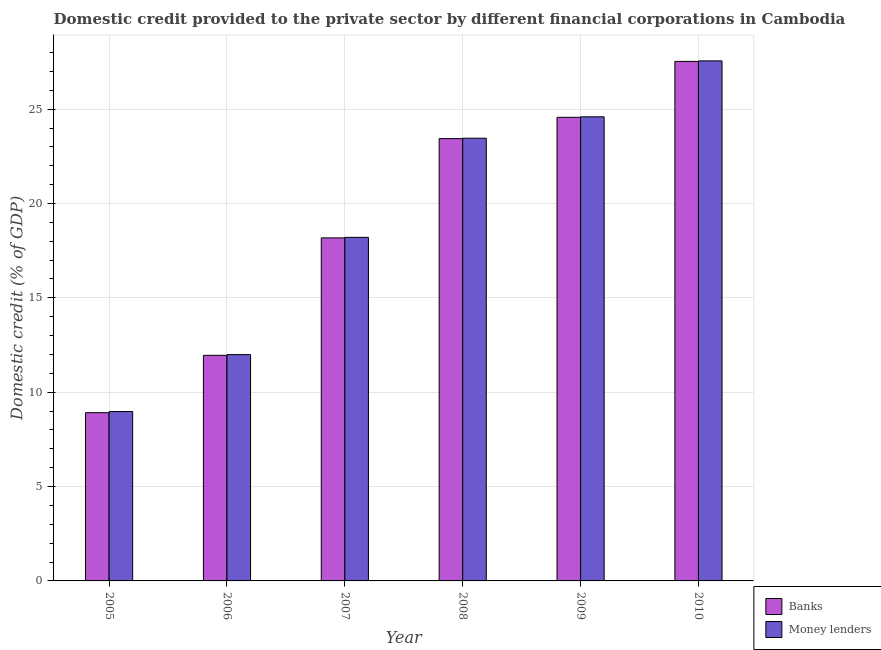How many different coloured bars are there?
Offer a very short reply. 2. How many groups of bars are there?
Your answer should be compact. 6. Are the number of bars per tick equal to the number of legend labels?
Offer a terse response. Yes. Are the number of bars on each tick of the X-axis equal?
Your answer should be compact. Yes. How many bars are there on the 3rd tick from the left?
Your answer should be very brief. 2. How many bars are there on the 5th tick from the right?
Make the answer very short. 2. What is the label of the 1st group of bars from the left?
Your answer should be very brief. 2005. What is the domestic credit provided by banks in 2006?
Provide a short and direct response. 11.95. Across all years, what is the maximum domestic credit provided by banks?
Provide a succinct answer. 27.53. Across all years, what is the minimum domestic credit provided by banks?
Provide a succinct answer. 8.92. In which year was the domestic credit provided by money lenders minimum?
Provide a short and direct response. 2005. What is the total domestic credit provided by money lenders in the graph?
Offer a very short reply. 114.79. What is the difference between the domestic credit provided by money lenders in 2006 and that in 2008?
Offer a terse response. -11.47. What is the difference between the domestic credit provided by money lenders in 2009 and the domestic credit provided by banks in 2006?
Your answer should be compact. 12.6. What is the average domestic credit provided by money lenders per year?
Offer a very short reply. 19.13. In how many years, is the domestic credit provided by money lenders greater than 5 %?
Your answer should be very brief. 6. What is the ratio of the domestic credit provided by banks in 2009 to that in 2010?
Offer a terse response. 0.89. What is the difference between the highest and the second highest domestic credit provided by money lenders?
Provide a succinct answer. 2.96. What is the difference between the highest and the lowest domestic credit provided by banks?
Ensure brevity in your answer.  18.61. What does the 1st bar from the left in 2008 represents?
Offer a terse response. Banks. What does the 1st bar from the right in 2006 represents?
Offer a terse response. Money lenders. How many years are there in the graph?
Your response must be concise. 6. Are the values on the major ticks of Y-axis written in scientific E-notation?
Provide a succinct answer. No. Where does the legend appear in the graph?
Offer a very short reply. Bottom right. How many legend labels are there?
Give a very brief answer. 2. How are the legend labels stacked?
Your answer should be compact. Vertical. What is the title of the graph?
Offer a terse response. Domestic credit provided to the private sector by different financial corporations in Cambodia. Does "Forest land" appear as one of the legend labels in the graph?
Your answer should be very brief. No. What is the label or title of the X-axis?
Keep it short and to the point. Year. What is the label or title of the Y-axis?
Provide a short and direct response. Domestic credit (% of GDP). What is the Domestic credit (% of GDP) in Banks in 2005?
Give a very brief answer. 8.92. What is the Domestic credit (% of GDP) in Money lenders in 2005?
Your answer should be compact. 8.98. What is the Domestic credit (% of GDP) of Banks in 2006?
Offer a very short reply. 11.95. What is the Domestic credit (% of GDP) in Money lenders in 2006?
Your answer should be compact. 11.99. What is the Domestic credit (% of GDP) in Banks in 2007?
Give a very brief answer. 18.18. What is the Domestic credit (% of GDP) in Money lenders in 2007?
Keep it short and to the point. 18.21. What is the Domestic credit (% of GDP) of Banks in 2008?
Ensure brevity in your answer.  23.44. What is the Domestic credit (% of GDP) in Money lenders in 2008?
Your answer should be very brief. 23.46. What is the Domestic credit (% of GDP) in Banks in 2009?
Your answer should be compact. 24.57. What is the Domestic credit (% of GDP) of Money lenders in 2009?
Ensure brevity in your answer.  24.59. What is the Domestic credit (% of GDP) of Banks in 2010?
Make the answer very short. 27.53. What is the Domestic credit (% of GDP) of Money lenders in 2010?
Offer a very short reply. 27.56. Across all years, what is the maximum Domestic credit (% of GDP) in Banks?
Offer a terse response. 27.53. Across all years, what is the maximum Domestic credit (% of GDP) in Money lenders?
Your answer should be compact. 27.56. Across all years, what is the minimum Domestic credit (% of GDP) of Banks?
Offer a very short reply. 8.92. Across all years, what is the minimum Domestic credit (% of GDP) of Money lenders?
Give a very brief answer. 8.98. What is the total Domestic credit (% of GDP) of Banks in the graph?
Your answer should be very brief. 114.58. What is the total Domestic credit (% of GDP) in Money lenders in the graph?
Provide a succinct answer. 114.79. What is the difference between the Domestic credit (% of GDP) of Banks in 2005 and that in 2006?
Offer a terse response. -3.04. What is the difference between the Domestic credit (% of GDP) of Money lenders in 2005 and that in 2006?
Make the answer very short. -3.02. What is the difference between the Domestic credit (% of GDP) of Banks in 2005 and that in 2007?
Keep it short and to the point. -9.26. What is the difference between the Domestic credit (% of GDP) in Money lenders in 2005 and that in 2007?
Keep it short and to the point. -9.23. What is the difference between the Domestic credit (% of GDP) of Banks in 2005 and that in 2008?
Ensure brevity in your answer.  -14.52. What is the difference between the Domestic credit (% of GDP) in Money lenders in 2005 and that in 2008?
Provide a succinct answer. -14.48. What is the difference between the Domestic credit (% of GDP) in Banks in 2005 and that in 2009?
Your answer should be very brief. -15.65. What is the difference between the Domestic credit (% of GDP) in Money lenders in 2005 and that in 2009?
Ensure brevity in your answer.  -15.62. What is the difference between the Domestic credit (% of GDP) in Banks in 2005 and that in 2010?
Your answer should be very brief. -18.61. What is the difference between the Domestic credit (% of GDP) in Money lenders in 2005 and that in 2010?
Offer a very short reply. -18.58. What is the difference between the Domestic credit (% of GDP) in Banks in 2006 and that in 2007?
Ensure brevity in your answer.  -6.22. What is the difference between the Domestic credit (% of GDP) of Money lenders in 2006 and that in 2007?
Offer a very short reply. -6.21. What is the difference between the Domestic credit (% of GDP) of Banks in 2006 and that in 2008?
Ensure brevity in your answer.  -11.49. What is the difference between the Domestic credit (% of GDP) in Money lenders in 2006 and that in 2008?
Ensure brevity in your answer.  -11.47. What is the difference between the Domestic credit (% of GDP) of Banks in 2006 and that in 2009?
Give a very brief answer. -12.61. What is the difference between the Domestic credit (% of GDP) of Money lenders in 2006 and that in 2009?
Your answer should be very brief. -12.6. What is the difference between the Domestic credit (% of GDP) in Banks in 2006 and that in 2010?
Your answer should be compact. -15.58. What is the difference between the Domestic credit (% of GDP) in Money lenders in 2006 and that in 2010?
Your answer should be compact. -15.57. What is the difference between the Domestic credit (% of GDP) of Banks in 2007 and that in 2008?
Your answer should be very brief. -5.26. What is the difference between the Domestic credit (% of GDP) of Money lenders in 2007 and that in 2008?
Offer a very short reply. -5.25. What is the difference between the Domestic credit (% of GDP) of Banks in 2007 and that in 2009?
Offer a very short reply. -6.39. What is the difference between the Domestic credit (% of GDP) of Money lenders in 2007 and that in 2009?
Your response must be concise. -6.39. What is the difference between the Domestic credit (% of GDP) of Banks in 2007 and that in 2010?
Ensure brevity in your answer.  -9.35. What is the difference between the Domestic credit (% of GDP) of Money lenders in 2007 and that in 2010?
Keep it short and to the point. -9.35. What is the difference between the Domestic credit (% of GDP) in Banks in 2008 and that in 2009?
Give a very brief answer. -1.13. What is the difference between the Domestic credit (% of GDP) in Money lenders in 2008 and that in 2009?
Your response must be concise. -1.13. What is the difference between the Domestic credit (% of GDP) of Banks in 2008 and that in 2010?
Provide a short and direct response. -4.09. What is the difference between the Domestic credit (% of GDP) in Money lenders in 2008 and that in 2010?
Offer a very short reply. -4.1. What is the difference between the Domestic credit (% of GDP) of Banks in 2009 and that in 2010?
Make the answer very short. -2.96. What is the difference between the Domestic credit (% of GDP) in Money lenders in 2009 and that in 2010?
Your answer should be very brief. -2.96. What is the difference between the Domestic credit (% of GDP) in Banks in 2005 and the Domestic credit (% of GDP) in Money lenders in 2006?
Offer a terse response. -3.08. What is the difference between the Domestic credit (% of GDP) of Banks in 2005 and the Domestic credit (% of GDP) of Money lenders in 2007?
Keep it short and to the point. -9.29. What is the difference between the Domestic credit (% of GDP) of Banks in 2005 and the Domestic credit (% of GDP) of Money lenders in 2008?
Provide a short and direct response. -14.54. What is the difference between the Domestic credit (% of GDP) in Banks in 2005 and the Domestic credit (% of GDP) in Money lenders in 2009?
Your response must be concise. -15.68. What is the difference between the Domestic credit (% of GDP) of Banks in 2005 and the Domestic credit (% of GDP) of Money lenders in 2010?
Provide a short and direct response. -18.64. What is the difference between the Domestic credit (% of GDP) of Banks in 2006 and the Domestic credit (% of GDP) of Money lenders in 2007?
Offer a very short reply. -6.25. What is the difference between the Domestic credit (% of GDP) in Banks in 2006 and the Domestic credit (% of GDP) in Money lenders in 2008?
Offer a terse response. -11.51. What is the difference between the Domestic credit (% of GDP) of Banks in 2006 and the Domestic credit (% of GDP) of Money lenders in 2009?
Make the answer very short. -12.64. What is the difference between the Domestic credit (% of GDP) of Banks in 2006 and the Domestic credit (% of GDP) of Money lenders in 2010?
Ensure brevity in your answer.  -15.6. What is the difference between the Domestic credit (% of GDP) in Banks in 2007 and the Domestic credit (% of GDP) in Money lenders in 2008?
Give a very brief answer. -5.28. What is the difference between the Domestic credit (% of GDP) in Banks in 2007 and the Domestic credit (% of GDP) in Money lenders in 2009?
Provide a succinct answer. -6.42. What is the difference between the Domestic credit (% of GDP) of Banks in 2007 and the Domestic credit (% of GDP) of Money lenders in 2010?
Provide a short and direct response. -9.38. What is the difference between the Domestic credit (% of GDP) in Banks in 2008 and the Domestic credit (% of GDP) in Money lenders in 2009?
Make the answer very short. -1.15. What is the difference between the Domestic credit (% of GDP) in Banks in 2008 and the Domestic credit (% of GDP) in Money lenders in 2010?
Make the answer very short. -4.12. What is the difference between the Domestic credit (% of GDP) of Banks in 2009 and the Domestic credit (% of GDP) of Money lenders in 2010?
Give a very brief answer. -2.99. What is the average Domestic credit (% of GDP) in Banks per year?
Your response must be concise. 19.1. What is the average Domestic credit (% of GDP) in Money lenders per year?
Offer a very short reply. 19.13. In the year 2005, what is the difference between the Domestic credit (% of GDP) of Banks and Domestic credit (% of GDP) of Money lenders?
Offer a very short reply. -0.06. In the year 2006, what is the difference between the Domestic credit (% of GDP) of Banks and Domestic credit (% of GDP) of Money lenders?
Your response must be concise. -0.04. In the year 2007, what is the difference between the Domestic credit (% of GDP) in Banks and Domestic credit (% of GDP) in Money lenders?
Ensure brevity in your answer.  -0.03. In the year 2008, what is the difference between the Domestic credit (% of GDP) of Banks and Domestic credit (% of GDP) of Money lenders?
Offer a very short reply. -0.02. In the year 2009, what is the difference between the Domestic credit (% of GDP) in Banks and Domestic credit (% of GDP) in Money lenders?
Ensure brevity in your answer.  -0.03. In the year 2010, what is the difference between the Domestic credit (% of GDP) in Banks and Domestic credit (% of GDP) in Money lenders?
Keep it short and to the point. -0.03. What is the ratio of the Domestic credit (% of GDP) of Banks in 2005 to that in 2006?
Provide a short and direct response. 0.75. What is the ratio of the Domestic credit (% of GDP) in Money lenders in 2005 to that in 2006?
Offer a terse response. 0.75. What is the ratio of the Domestic credit (% of GDP) of Banks in 2005 to that in 2007?
Keep it short and to the point. 0.49. What is the ratio of the Domestic credit (% of GDP) of Money lenders in 2005 to that in 2007?
Offer a very short reply. 0.49. What is the ratio of the Domestic credit (% of GDP) of Banks in 2005 to that in 2008?
Ensure brevity in your answer.  0.38. What is the ratio of the Domestic credit (% of GDP) of Money lenders in 2005 to that in 2008?
Offer a terse response. 0.38. What is the ratio of the Domestic credit (% of GDP) in Banks in 2005 to that in 2009?
Give a very brief answer. 0.36. What is the ratio of the Domestic credit (% of GDP) in Money lenders in 2005 to that in 2009?
Offer a very short reply. 0.36. What is the ratio of the Domestic credit (% of GDP) in Banks in 2005 to that in 2010?
Your response must be concise. 0.32. What is the ratio of the Domestic credit (% of GDP) in Money lenders in 2005 to that in 2010?
Keep it short and to the point. 0.33. What is the ratio of the Domestic credit (% of GDP) of Banks in 2006 to that in 2007?
Keep it short and to the point. 0.66. What is the ratio of the Domestic credit (% of GDP) in Money lenders in 2006 to that in 2007?
Make the answer very short. 0.66. What is the ratio of the Domestic credit (% of GDP) in Banks in 2006 to that in 2008?
Offer a terse response. 0.51. What is the ratio of the Domestic credit (% of GDP) of Money lenders in 2006 to that in 2008?
Offer a very short reply. 0.51. What is the ratio of the Domestic credit (% of GDP) in Banks in 2006 to that in 2009?
Ensure brevity in your answer.  0.49. What is the ratio of the Domestic credit (% of GDP) in Money lenders in 2006 to that in 2009?
Make the answer very short. 0.49. What is the ratio of the Domestic credit (% of GDP) of Banks in 2006 to that in 2010?
Your response must be concise. 0.43. What is the ratio of the Domestic credit (% of GDP) in Money lenders in 2006 to that in 2010?
Provide a succinct answer. 0.44. What is the ratio of the Domestic credit (% of GDP) of Banks in 2007 to that in 2008?
Your response must be concise. 0.78. What is the ratio of the Domestic credit (% of GDP) in Money lenders in 2007 to that in 2008?
Your response must be concise. 0.78. What is the ratio of the Domestic credit (% of GDP) of Banks in 2007 to that in 2009?
Offer a very short reply. 0.74. What is the ratio of the Domestic credit (% of GDP) of Money lenders in 2007 to that in 2009?
Provide a succinct answer. 0.74. What is the ratio of the Domestic credit (% of GDP) of Banks in 2007 to that in 2010?
Your answer should be very brief. 0.66. What is the ratio of the Domestic credit (% of GDP) in Money lenders in 2007 to that in 2010?
Offer a very short reply. 0.66. What is the ratio of the Domestic credit (% of GDP) in Banks in 2008 to that in 2009?
Keep it short and to the point. 0.95. What is the ratio of the Domestic credit (% of GDP) in Money lenders in 2008 to that in 2009?
Offer a terse response. 0.95. What is the ratio of the Domestic credit (% of GDP) of Banks in 2008 to that in 2010?
Offer a terse response. 0.85. What is the ratio of the Domestic credit (% of GDP) in Money lenders in 2008 to that in 2010?
Make the answer very short. 0.85. What is the ratio of the Domestic credit (% of GDP) of Banks in 2009 to that in 2010?
Provide a succinct answer. 0.89. What is the ratio of the Domestic credit (% of GDP) of Money lenders in 2009 to that in 2010?
Offer a terse response. 0.89. What is the difference between the highest and the second highest Domestic credit (% of GDP) of Banks?
Offer a very short reply. 2.96. What is the difference between the highest and the second highest Domestic credit (% of GDP) in Money lenders?
Offer a very short reply. 2.96. What is the difference between the highest and the lowest Domestic credit (% of GDP) in Banks?
Your response must be concise. 18.61. What is the difference between the highest and the lowest Domestic credit (% of GDP) in Money lenders?
Ensure brevity in your answer.  18.58. 